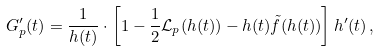<formula> <loc_0><loc_0><loc_500><loc_500>G _ { p } ^ { \prime } ( t ) = \frac { 1 } { h ( t ) } \cdot \left [ 1 - \frac { 1 } { 2 } \mathcal { L } _ { p } ( h ( t ) ) - h ( t ) \tilde { f } ( h ( t ) ) \right ] h ^ { \prime } ( t ) \, ,</formula> 